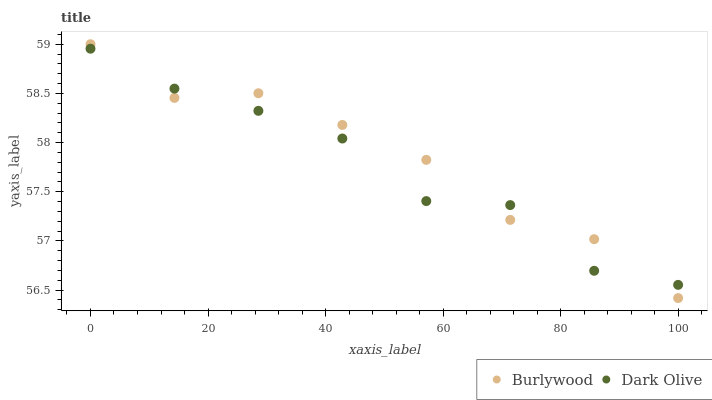Does Dark Olive have the minimum area under the curve?
Answer yes or no. Yes. Does Burlywood have the maximum area under the curve?
Answer yes or no. Yes. Does Dark Olive have the maximum area under the curve?
Answer yes or no. No. Is Burlywood the smoothest?
Answer yes or no. Yes. Is Dark Olive the roughest?
Answer yes or no. Yes. Is Dark Olive the smoothest?
Answer yes or no. No. Does Burlywood have the lowest value?
Answer yes or no. Yes. Does Dark Olive have the lowest value?
Answer yes or no. No. Does Burlywood have the highest value?
Answer yes or no. Yes. Does Dark Olive have the highest value?
Answer yes or no. No. Does Burlywood intersect Dark Olive?
Answer yes or no. Yes. Is Burlywood less than Dark Olive?
Answer yes or no. No. Is Burlywood greater than Dark Olive?
Answer yes or no. No. 